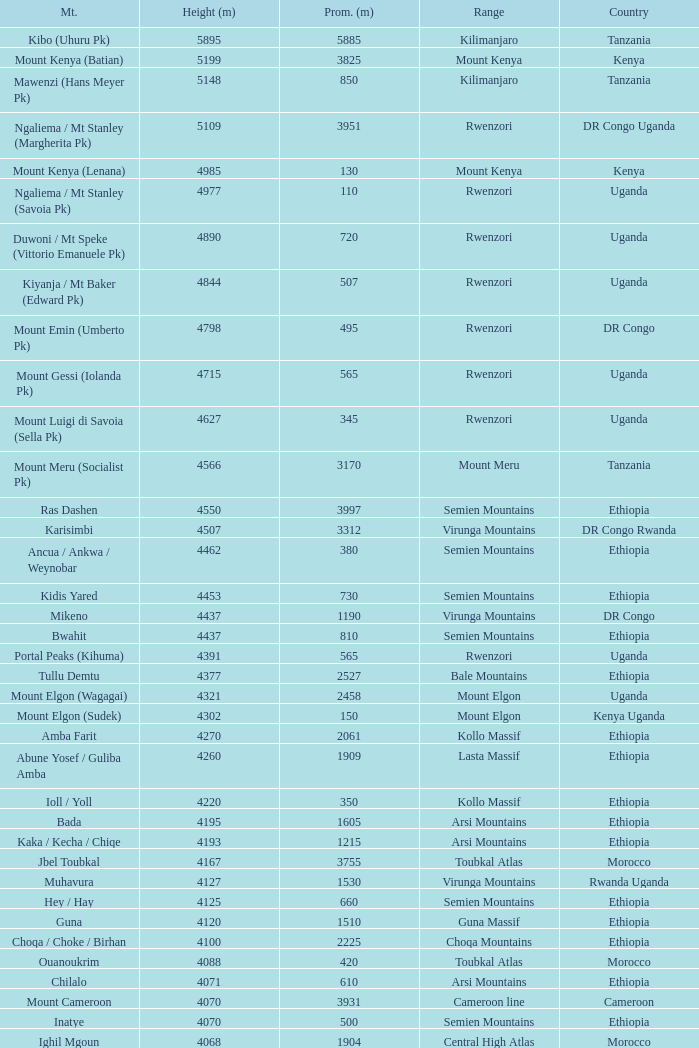Which Country has a Prominence (m) smaller than 1540, and a Height (m) smaller than 3530, and a Range of virunga mountains, and a Mountain of nyiragongo? DR Congo. 